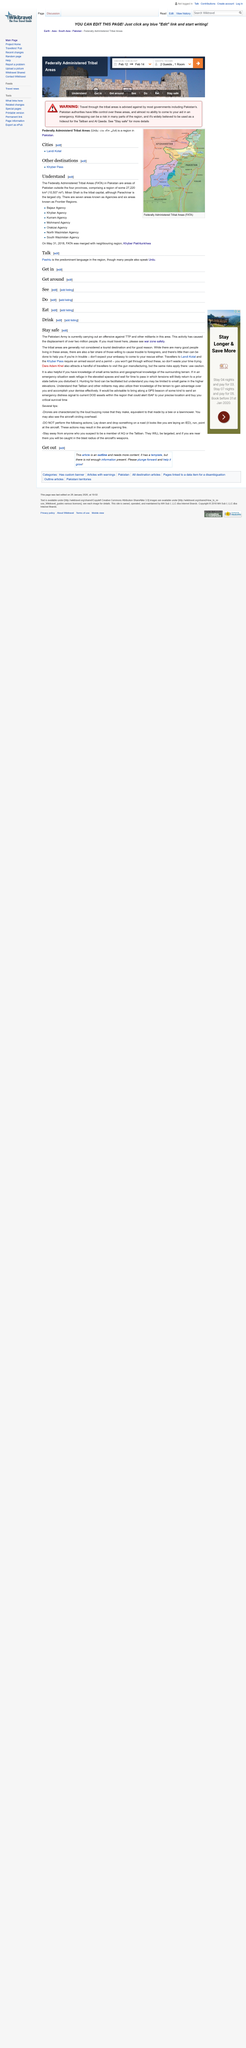Identify some key points in this picture. It is helpful to have knowledge of small arms tactics and geographical knowledge of the surrounding terrain in order to effectively carry out small arms tactics training. The Pakistani Army is currently engaged in an offensive operation against the Tehreek-e-Taliban Pakistan (TTP) and other militant groups in the area. It is essential for travelers to Landi Kotal and the Kyhber Pass to obtain an armed escort and a permit in order to ensure their safety and compliance with local regulations. 